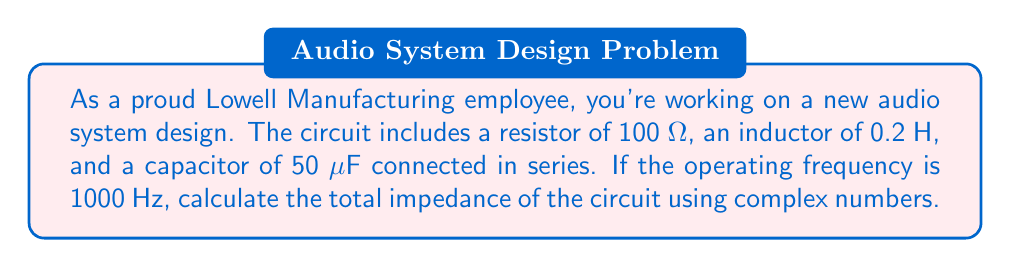Give your solution to this math problem. Let's approach this step-by-step:

1) First, we need to calculate the reactances of the inductor and capacitor:

   Inductive reactance: $X_L = 2\pi fL$
   where $f$ is frequency and $L$ is inductance
   
   $X_L = 2\pi \cdot 1000 \cdot 0.2 = 1256.64$ Ω

   Capacitive reactance: $X_C = \frac{1}{2\pi fC}$
   where $C$ is capacitance in Farads
   
   $X_C = \frac{1}{2\pi \cdot 1000 \cdot 50 \times 10^{-6}} = 3183.10$ Ω

2) Now, we can represent each component in complex form:
   
   Resistor: $R = 100$ Ω
   Inductor: $j X_L = j 1256.64$ Ω
   Capacitor: $-j X_C = -j 3183.10$ Ω

3) In a series circuit, we add the impedances:

   $Z = R + j X_L - j X_C$
   
   $Z = 100 + j 1256.64 - j 3183.10$
   
   $Z = 100 - j 1926.46$

4) To find the magnitude of the impedance, we use the formula:

   $|Z| = \sqrt{R^2 + (X_L - X_C)^2}$

   $|Z| = \sqrt{100^2 + (-1926.46)^2} = 1929.37$ Ω

5) To find the phase angle, we use:

   $\theta = \tan^{-1}(\frac{X_L - X_C}{R})$

   $\theta = \tan^{-1}(\frac{-1926.46}{100}) = -87.03°$

Therefore, the total impedance in polar form is:

$Z = 1929.37 \angle -87.03°$ Ω

Or in rectangular form:

$Z = 100 - j 1926.46$ Ω
Answer: $Z = 1929.37 \angle -87.03°$ Ω or $Z = 100 - j 1926.46$ Ω 